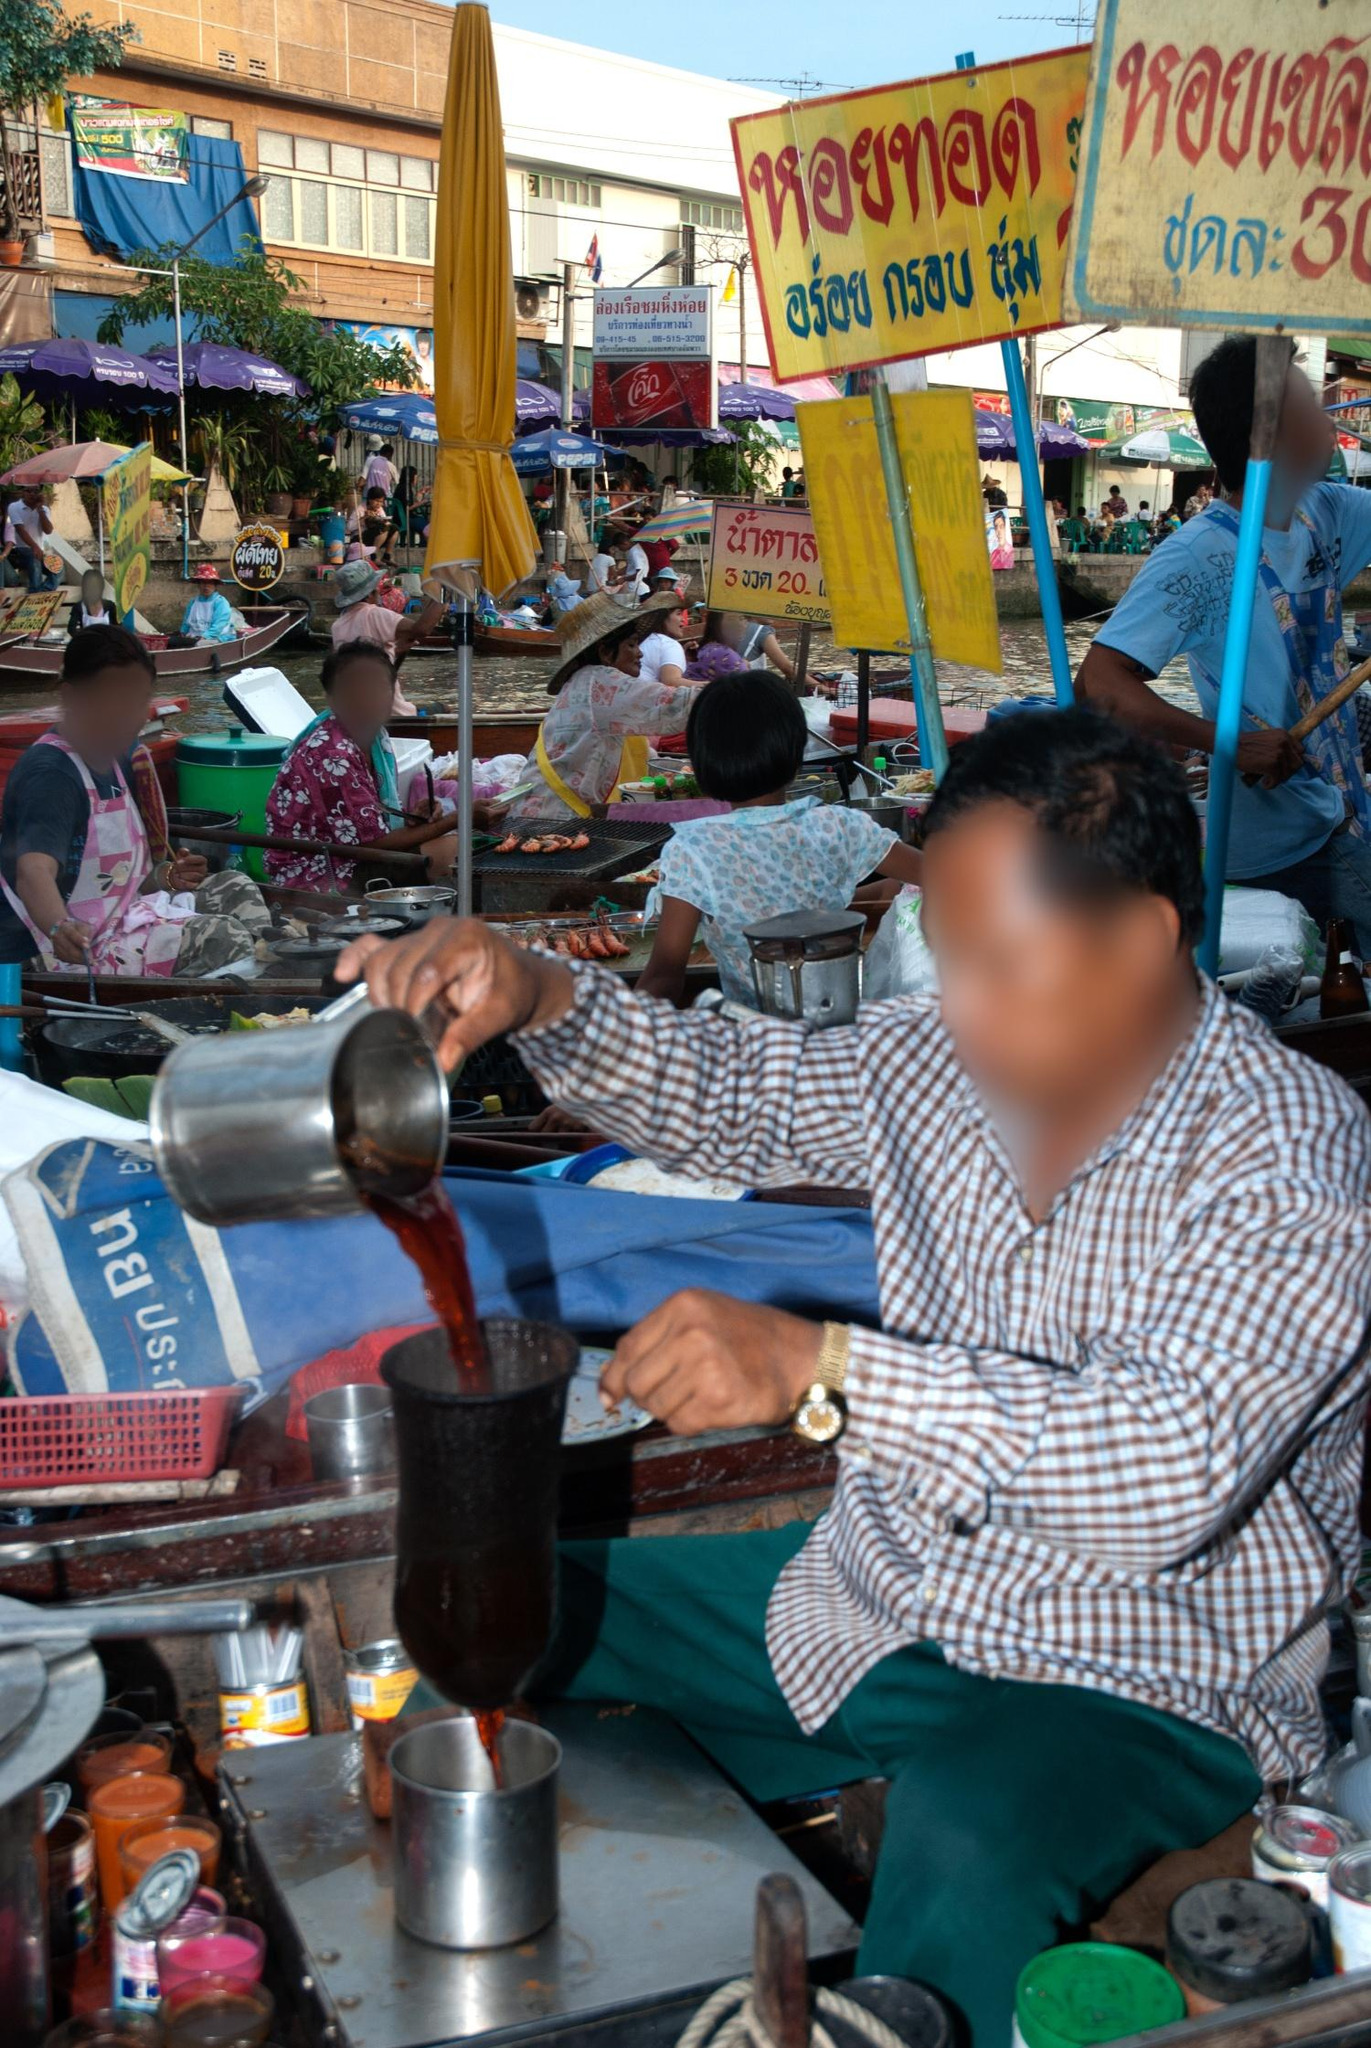Can you describe the main features of this image for me? The image vividly captures the dynamic atmosphere of a floating market in Thailand. Central to the scene is a man skillfully pouring a vibrant red liquid into a metallic cup, surrounded by an assortment of colorful bottles and containers on his table. The backdrop is bustling with activity, featuring numerous boats, vendors, and shoppers, set against a lively marketplace filled with food stalls and various signs written in Thai, which add to the cultural ambiance. One notable sign in the clear overhead reads "ร้านขายน้ำผึ้ง สด 20 บาท", translating to "Fresh honey drink shop, 20 baht". The image presents a unique perspective from the side angle, offering an immersive glimpse into the vibrant, daily life at a Thai floating market enriched with a palette of radiant colors and diverse activities. 